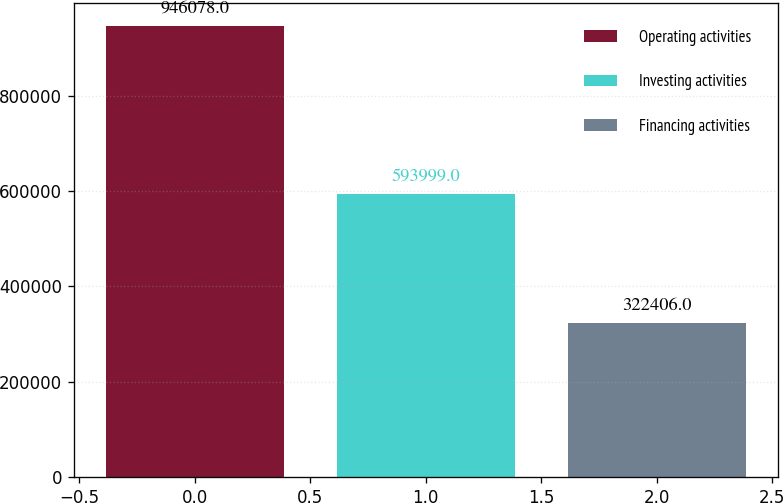Convert chart. <chart><loc_0><loc_0><loc_500><loc_500><bar_chart><fcel>Operating activities<fcel>Investing activities<fcel>Financing activities<nl><fcel>946078<fcel>593999<fcel>322406<nl></chart> 